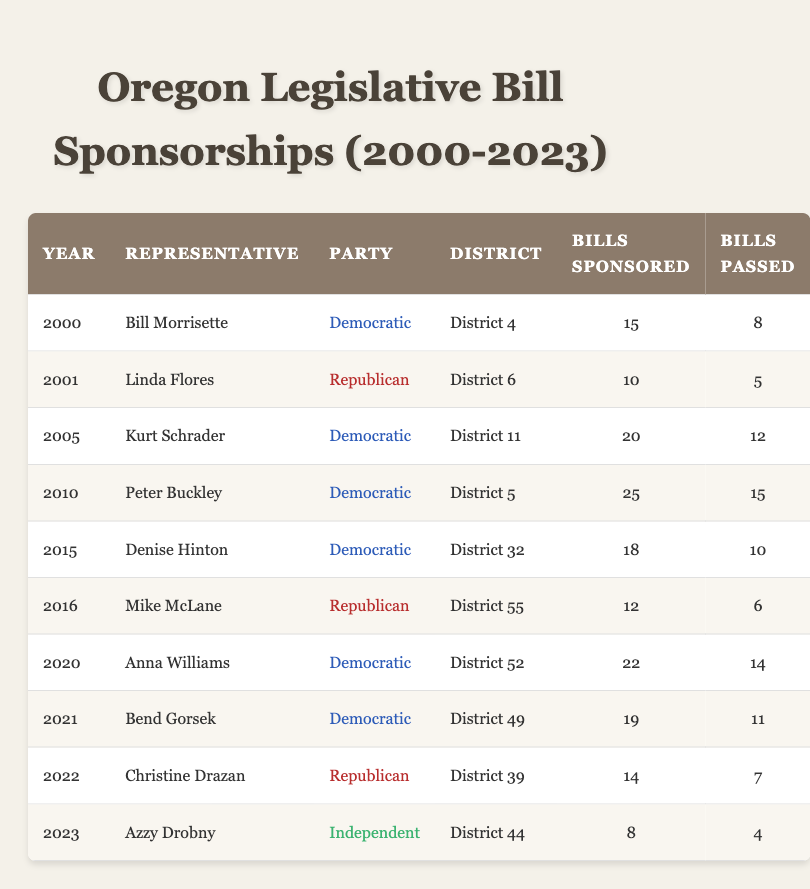What was the year when the most bills were sponsored? By reviewing the table, I can see that Peter Buckley sponsored a total of 25 bills in 2010, which is the highest number recorded for any year from 2000 to 2023.
Answer: 2010 How many bills did Azzy Drobny sponsor in 2023? The table shows that Azzy Drobny sponsored a total of 8 bills in 2023.
Answer: 8 Which party had the highest number of total bills passed? To determine this, I will sum the bills passed for each party: Democratic (8 + 12 + 15 + 10 + 14 + 11 = 70), Republican (5 + 6 + 7 = 18), Independent (4 = 4). The Democratic Party has 70, which is the highest total.
Answer: Democratic Did Denise Hinton sponsor more bills than Kurt Schrader? Denise Hinton sponsored 18 bills in 2015 while Kurt Schrader sponsored 20 bills in 2005. Since 18 is less than 20, the statement is not true.
Answer: No What is the average number of bills sponsored by Republican representatives? The Republican representatives sponsored the following bills: Linda Flores (10), Mike McLane (12), Christine Drazan (14). Summing these values gives 10 + 12 + 14 = 36. There are 3 Republican representatives, so the average is 36 / 3 = 12.
Answer: 12 Which district did the representative with the highest number of bills passed represent? Peter Buckley, a Democratic representative from District 5, passed 15 bills, which is the highest number of bills passed by any representative in the table. Thus, District 5 is correct.
Answer: District 5 How many total bills were sponsored in the year 2022? The table shows Christine Drazan sponsored 14 bills in 2022. Hence, the total number of bills sponsored in that year is 14.
Answer: 14 Did any Independent representative sponsor more bills than Democratic representatives? Azzy Drobny, an Independent representative, sponsored 8 bills, while several Democratic representatives sponsored more: for example, Peter Buckley with 25 and Kurt Schrader with 20. Therefore, no Independent sponsored more.
Answer: No 